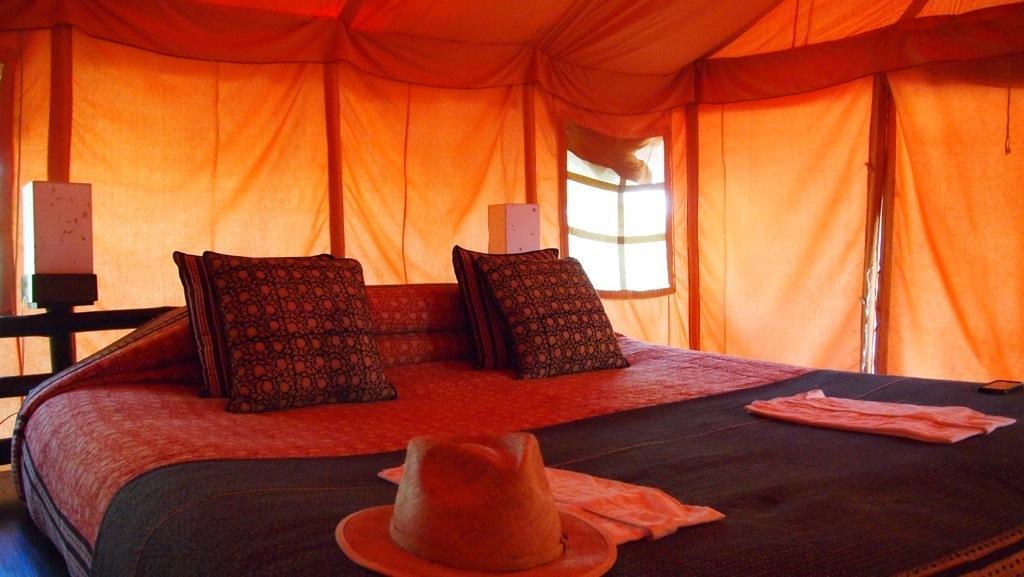How would you summarize this image in a sentence or two? In this picture we can see pillows, hat, cloth and bed sheet on the bed. Here we can see boxes. On the top we can see orange color tint. 